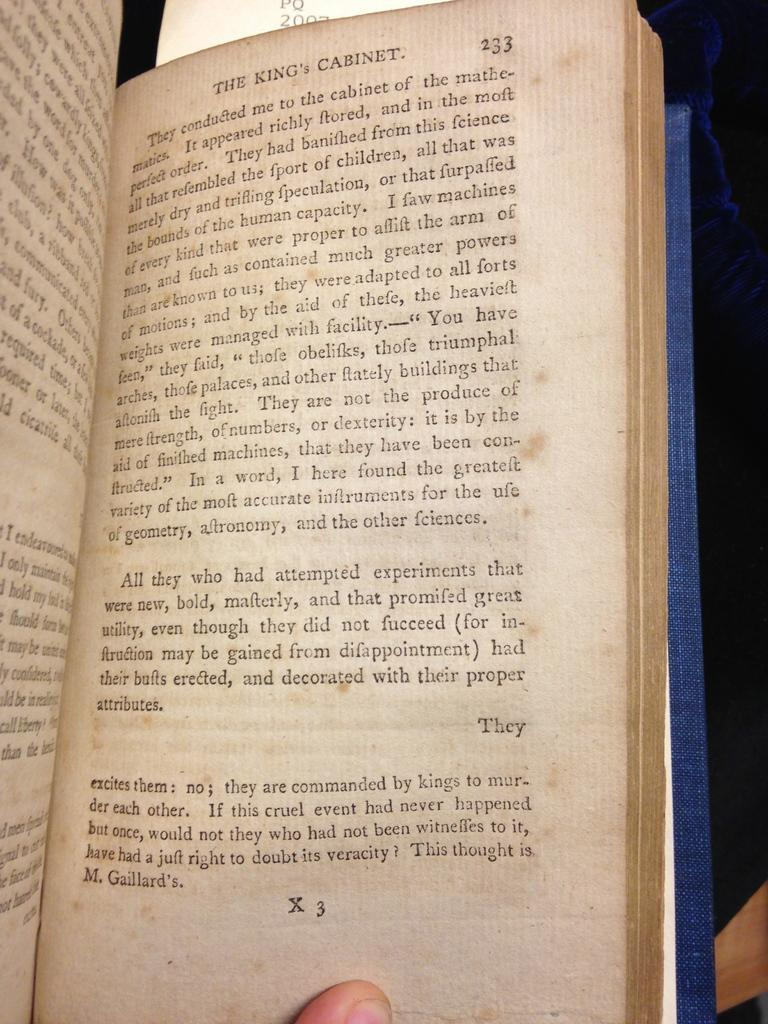<image>
Give a short and clear explanation of the subsequent image. Page 233 is open of the book called The King's Cabinet. 